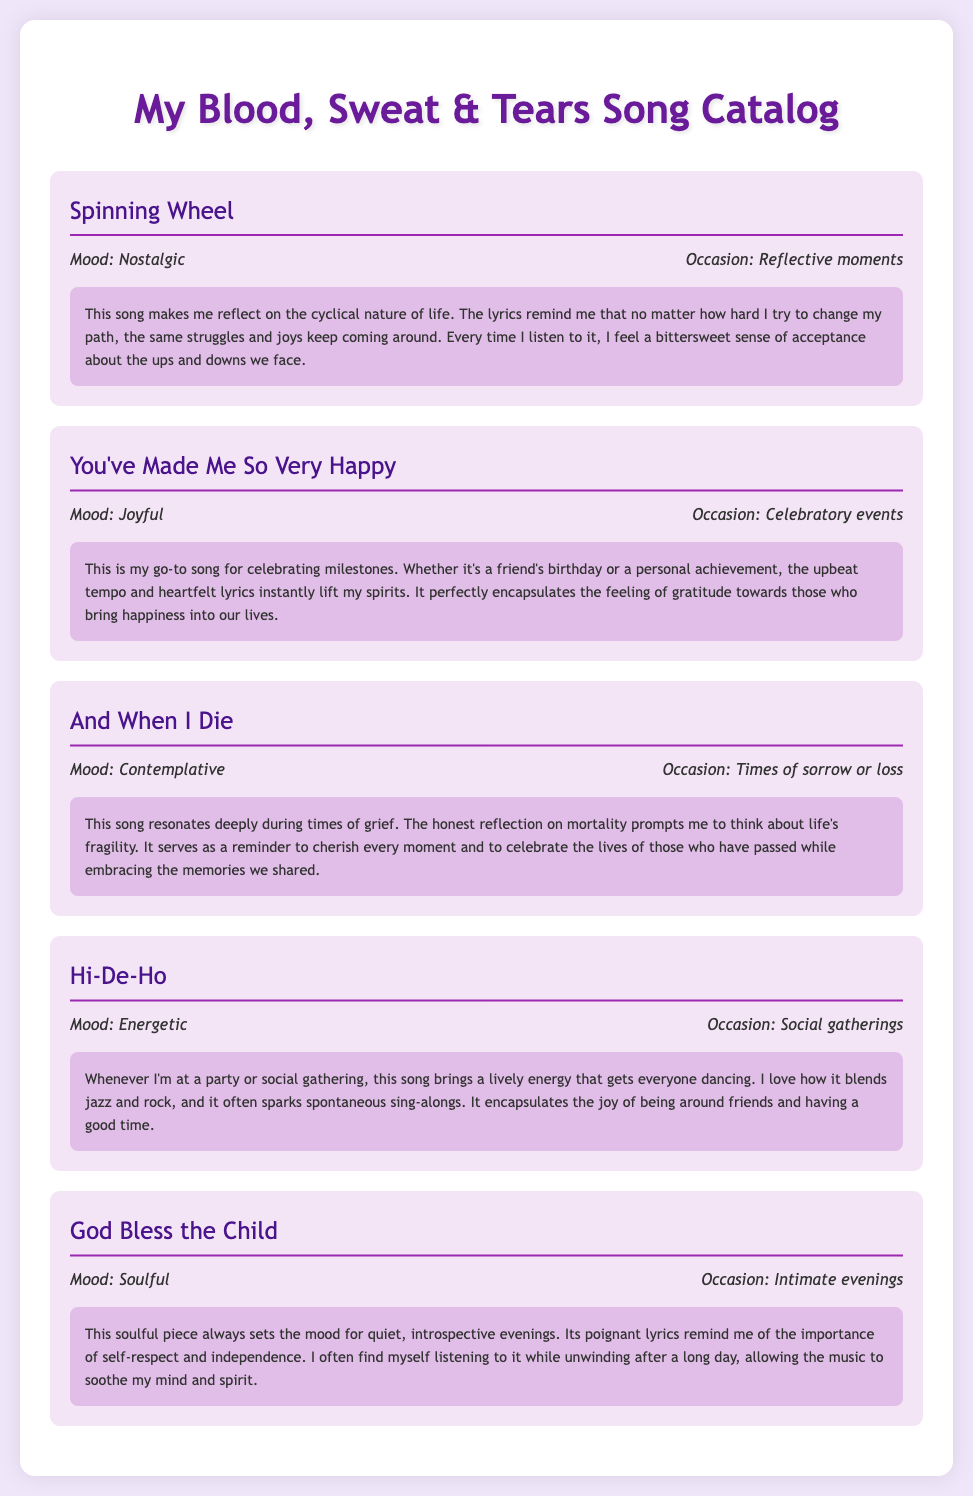What song is categorized under "Nostalgic" mood? The song "Spinning Wheel" is categorized under the mood of "Nostalgic."
Answer: Spinning Wheel What is the occasion associated with "You've Made Me So Very Happy"? The occasion associated with "You've Made Me So Very Happy" is "Celebratory events."
Answer: Celebratory events Which song reflects on mortality? The song "And When I Die" reflects on mortality.
Answer: And When I Die What mood is "Hi-De-Ho" categorized under? "Hi-De-Ho" is categorized under the mood of "Energetic."
Answer: Energetic During which occasions is "God Bless the Child" typically listened to? "God Bless the Child" is typically listened to during "Intimate evenings."
Answer: Intimate evenings What common theme is found in the reflections of "And When I Die"? The common theme found in the reflections of "And When I Die" is the "fragility of life."
Answer: Fragility of life How does "Hi-De-Ho" affect social gatherings? "Hi-De-Ho" brings a lively energy that gets everyone dancing at social gatherings.
Answer: Lively energy What type of music does "Hi-De-Ho" blend? "Hi-De-Ho" blends jazz and rock music styles.
Answer: Jazz and rock What feeling does "You've Made Me So Very Happy" convey? "You've Made Me So Very Happy" conveys a feeling of "gratitude."
Answer: Gratitude 